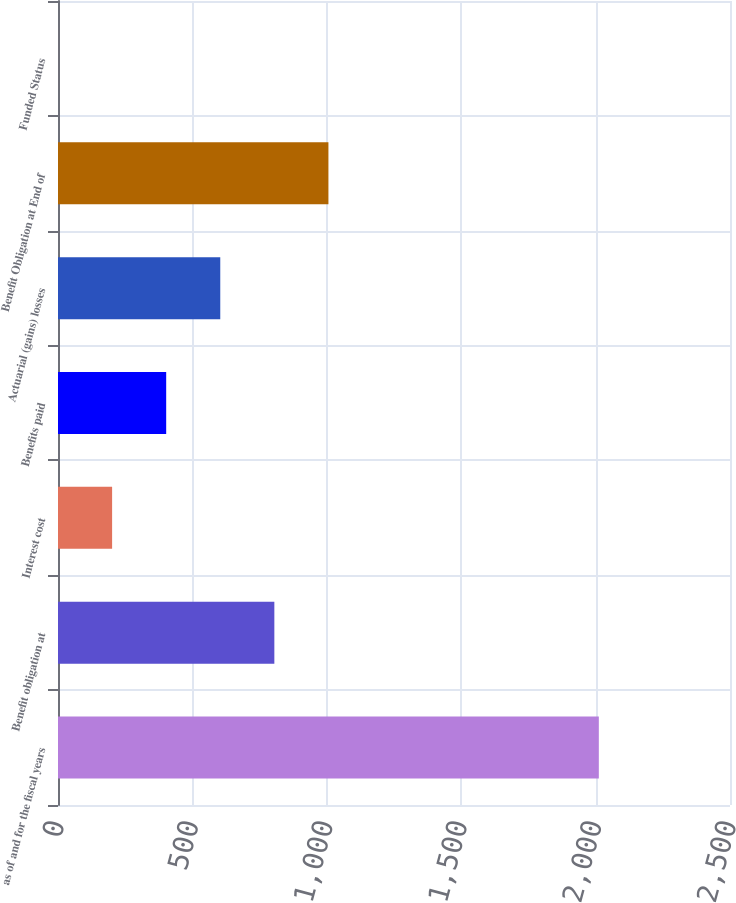<chart> <loc_0><loc_0><loc_500><loc_500><bar_chart><fcel>as of and for the fiscal years<fcel>Benefit obligation at<fcel>Interest cost<fcel>Benefits paid<fcel>Actuarial (gains) losses<fcel>Benefit Obligation at End of<fcel>Funded Status<nl><fcel>2012<fcel>804.86<fcel>201.29<fcel>402.48<fcel>603.67<fcel>1006.05<fcel>0.1<nl></chart> 